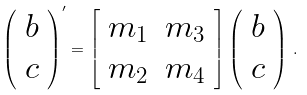Convert formula to latex. <formula><loc_0><loc_0><loc_500><loc_500>\left ( \begin{array} { c } b \\ c \end{array} \right ) ^ { \prime } = \left [ \begin{array} { c c } m _ { 1 } & m _ { 3 } \\ m _ { 2 } & m _ { 4 } \end{array} \right ] \left ( \begin{array} { c } b \\ c \end{array} \right ) \, .</formula> 